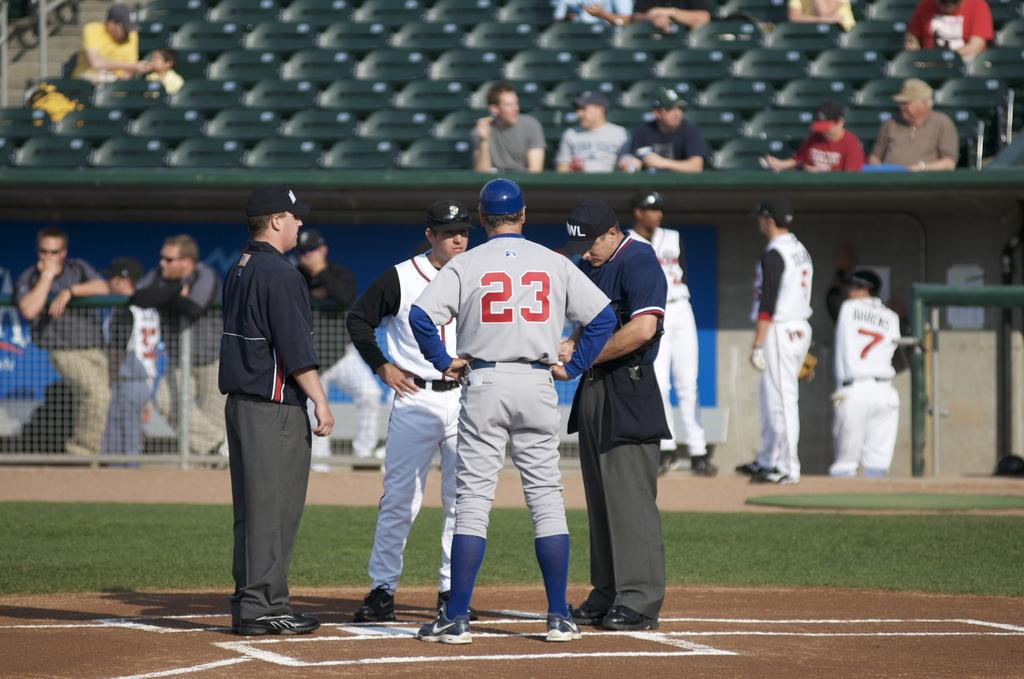Provide a one-sentence caption for the provided image. Baseball player with number 23 stands on the mound next to two umpires. 